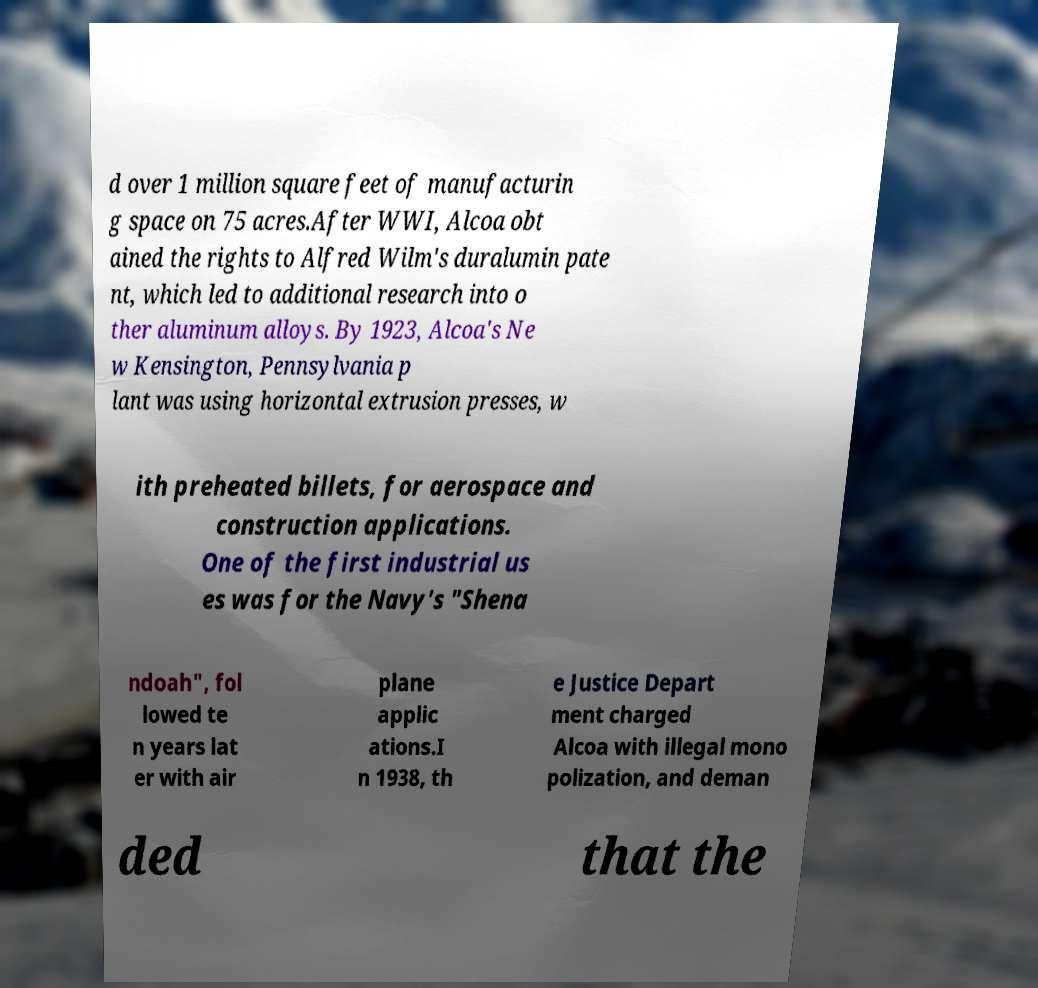Please identify and transcribe the text found in this image. d over 1 million square feet of manufacturin g space on 75 acres.After WWI, Alcoa obt ained the rights to Alfred Wilm's duralumin pate nt, which led to additional research into o ther aluminum alloys. By 1923, Alcoa's Ne w Kensington, Pennsylvania p lant was using horizontal extrusion presses, w ith preheated billets, for aerospace and construction applications. One of the first industrial us es was for the Navy's "Shena ndoah", fol lowed te n years lat er with air plane applic ations.I n 1938, th e Justice Depart ment charged Alcoa with illegal mono polization, and deman ded that the 